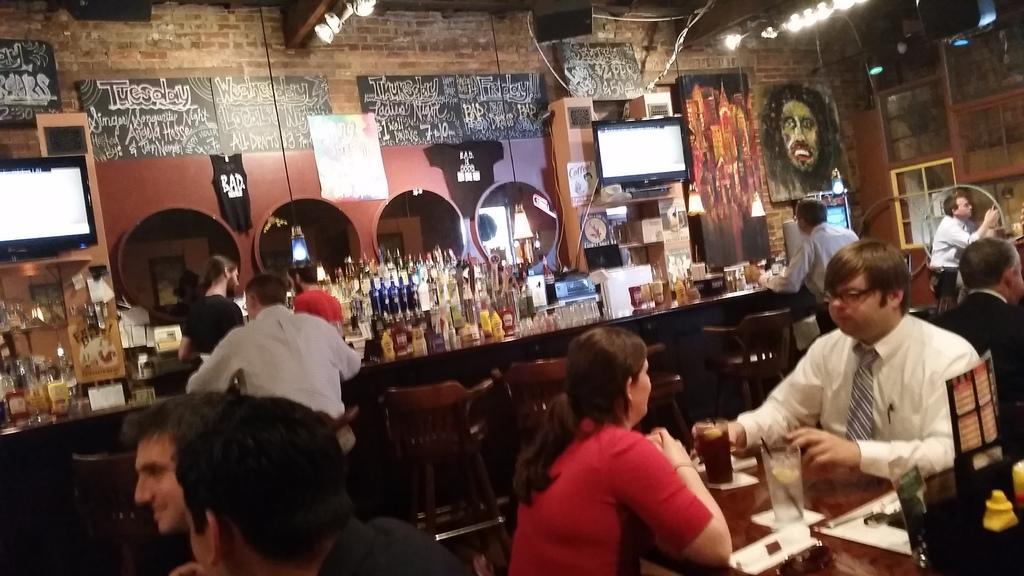Can you describe this image briefly? In this image we can see some group of persons who are sitting on chairs around tables having some food and drinks and at the background of the image there are some persons standing behind the block on which there are some bottles glasses and some food items, there are screens and some paintings attached to the wall. 